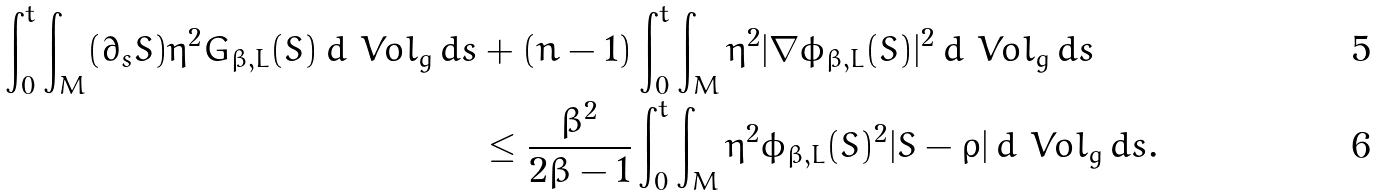Convert formula to latex. <formula><loc_0><loc_0><loc_500><loc_500>\int _ { 0 } ^ { t } \int _ { M } ( \partial _ { s } S ) \eta ^ { 2 } G _ { \beta , L } ( S ) \, d \ V o l _ { g } \, d s & + ( n - 1 ) \int _ { 0 } ^ { t } \int _ { M } \eta ^ { 2 } | \nabla \phi _ { \beta , L } ( S ) | ^ { 2 } \, d \ V o l _ { g } \, d s \\ & \leq \frac { \beta ^ { 2 } } { 2 \beta - 1 } \int _ { 0 } ^ { t } \int _ { M } \eta ^ { 2 } \phi _ { \beta , L } ( S ) ^ { 2 } | S - \rho | \, d \ V o l _ { g } \, d s .</formula> 